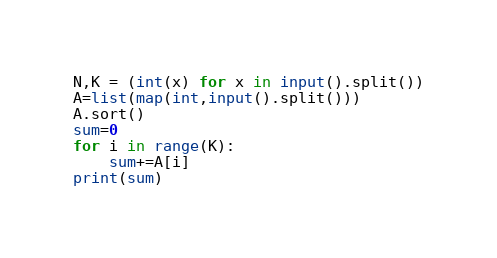<code> <loc_0><loc_0><loc_500><loc_500><_Python_>N,K = (int(x) for x in input().split())
A=list(map(int,input().split()))
A.sort()
sum=0
for i in range(K):
    sum+=A[i]
print(sum)</code> 